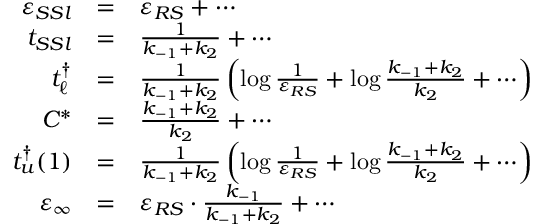<formula> <loc_0><loc_0><loc_500><loc_500>\begin{array} { r c l } { \varepsilon _ { S S l } } & { = } & { \varepsilon _ { R S } + \cdots } \\ { t _ { S S l } } & { = } & { \frac { 1 } { k _ { - 1 } + k _ { 2 } } + \cdots } \\ { t _ { \ell } ^ { \dagger } } & { = } & { \frac { 1 } { k _ { - 1 } + k _ { 2 } } \left ( \log \frac { 1 } { \varepsilon _ { R S } } + \log \frac { k _ { - 1 } + k _ { 2 } } { k _ { 2 } } + \cdots \right ) } \\ { C ^ { * } } & { = } & { \frac { k _ { - 1 } + k _ { 2 } } { k _ { 2 } } + \cdots } \\ { t _ { u } ^ { \dagger } ( 1 ) } & { = } & { \frac { 1 } { k _ { - 1 } + k _ { 2 } } \left ( \log \frac { 1 } { \varepsilon _ { R S } } + \log \frac { k _ { - 1 } + k _ { 2 } } { k _ { 2 } } + \cdots \right ) } \\ { \varepsilon _ { \infty } } & { = } & { \varepsilon _ { R S } \cdot \frac { k _ { - 1 } } { k _ { - 1 } + k _ { 2 } } + \cdots } \end{array}</formula> 